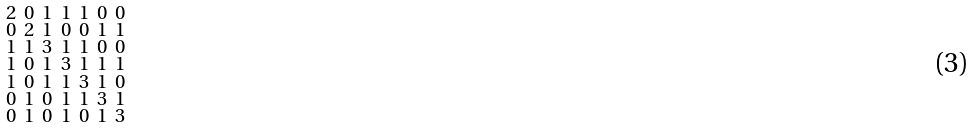Convert formula to latex. <formula><loc_0><loc_0><loc_500><loc_500>\begin{smallmatrix} 2 & 0 & 1 & 1 & 1 & 0 & 0 \\ 0 & 2 & 1 & 0 & 0 & 1 & 1 \\ 1 & 1 & 3 & 1 & 1 & 0 & 0 \\ 1 & 0 & 1 & 3 & 1 & 1 & 1 \\ 1 & 0 & 1 & 1 & 3 & 1 & 0 \\ 0 & 1 & 0 & 1 & 1 & 3 & 1 \\ 0 & 1 & 0 & 1 & 0 & 1 & 3 \end{smallmatrix}</formula> 